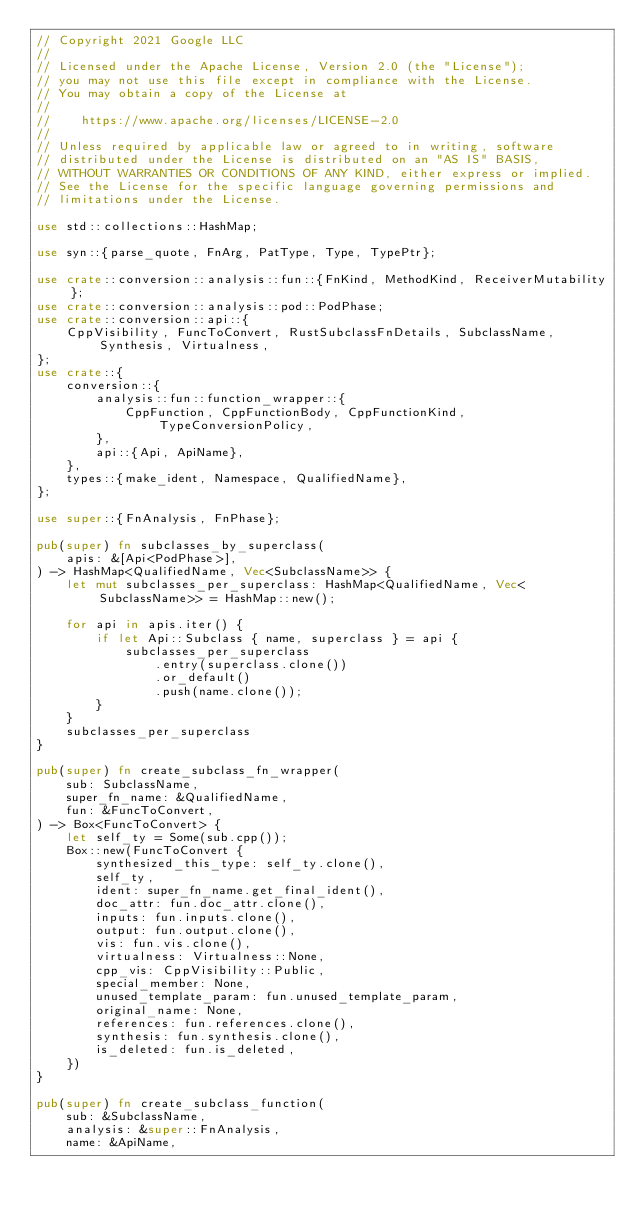Convert code to text. <code><loc_0><loc_0><loc_500><loc_500><_Rust_>// Copyright 2021 Google LLC
//
// Licensed under the Apache License, Version 2.0 (the "License");
// you may not use this file except in compliance with the License.
// You may obtain a copy of the License at
//
//    https://www.apache.org/licenses/LICENSE-2.0
//
// Unless required by applicable law or agreed to in writing, software
// distributed under the License is distributed on an "AS IS" BASIS,
// WITHOUT WARRANTIES OR CONDITIONS OF ANY KIND, either express or implied.
// See the License for the specific language governing permissions and
// limitations under the License.

use std::collections::HashMap;

use syn::{parse_quote, FnArg, PatType, Type, TypePtr};

use crate::conversion::analysis::fun::{FnKind, MethodKind, ReceiverMutability};
use crate::conversion::analysis::pod::PodPhase;
use crate::conversion::api::{
    CppVisibility, FuncToConvert, RustSubclassFnDetails, SubclassName, Synthesis, Virtualness,
};
use crate::{
    conversion::{
        analysis::fun::function_wrapper::{
            CppFunction, CppFunctionBody, CppFunctionKind, TypeConversionPolicy,
        },
        api::{Api, ApiName},
    },
    types::{make_ident, Namespace, QualifiedName},
};

use super::{FnAnalysis, FnPhase};

pub(super) fn subclasses_by_superclass(
    apis: &[Api<PodPhase>],
) -> HashMap<QualifiedName, Vec<SubclassName>> {
    let mut subclasses_per_superclass: HashMap<QualifiedName, Vec<SubclassName>> = HashMap::new();

    for api in apis.iter() {
        if let Api::Subclass { name, superclass } = api {
            subclasses_per_superclass
                .entry(superclass.clone())
                .or_default()
                .push(name.clone());
        }
    }
    subclasses_per_superclass
}

pub(super) fn create_subclass_fn_wrapper(
    sub: SubclassName,
    super_fn_name: &QualifiedName,
    fun: &FuncToConvert,
) -> Box<FuncToConvert> {
    let self_ty = Some(sub.cpp());
    Box::new(FuncToConvert {
        synthesized_this_type: self_ty.clone(),
        self_ty,
        ident: super_fn_name.get_final_ident(),
        doc_attr: fun.doc_attr.clone(),
        inputs: fun.inputs.clone(),
        output: fun.output.clone(),
        vis: fun.vis.clone(),
        virtualness: Virtualness::None,
        cpp_vis: CppVisibility::Public,
        special_member: None,
        unused_template_param: fun.unused_template_param,
        original_name: None,
        references: fun.references.clone(),
        synthesis: fun.synthesis.clone(),
        is_deleted: fun.is_deleted,
    })
}

pub(super) fn create_subclass_function(
    sub: &SubclassName,
    analysis: &super::FnAnalysis,
    name: &ApiName,</code> 